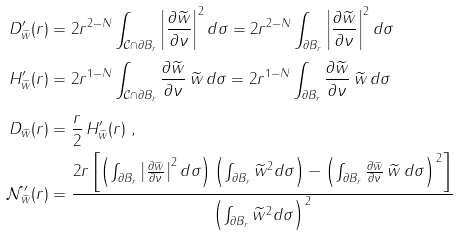<formula> <loc_0><loc_0><loc_500><loc_500>D ^ { \prime } _ { \widetilde { w } } ( r ) & = 2 r ^ { 2 - N } \int _ { \mathcal { C } \cap \partial B _ { r } } \left | \frac { \partial \widetilde { w } } { \partial \nu } \right | ^ { 2 } d \sigma = 2 r ^ { 2 - N } \int _ { \partial B _ { r } } \left | \frac { \partial \widetilde { w } } { \partial \nu } \right | ^ { 2 } d \sigma \\ H ^ { \prime } _ { \widetilde { w } } ( r ) & = 2 r ^ { 1 - N } \int _ { \mathcal { C } \cap \partial B _ { r } } \frac { \partial \widetilde { w } } { \partial \nu } \, \widetilde { w } \, d \sigma = 2 r ^ { 1 - N } \int _ { \partial B _ { r } } \frac { \partial \widetilde { w } } { \partial \nu } \, \widetilde { w } \, d \sigma \\ D _ { \widetilde { w } } ( r ) & = \frac { r } 2 \, H ^ { \prime } _ { \widetilde { w } } ( r ) \ , \\ \mathcal { N } ^ { \prime } _ { \widetilde { w } } ( r ) & = \frac { 2 r \left [ \left ( \int _ { \partial B _ { r } } \left | \frac { \partial \widetilde { w } } { \partial \nu } \right | ^ { 2 } d \sigma \right ) \left ( \int _ { \partial B _ { r } } \widetilde { w } ^ { 2 } d \sigma \right ) - \left ( \int _ { \partial B _ { r } } \frac { \partial \widetilde { w } } { \partial \nu } \, \widetilde { w } \, d \sigma \right ) ^ { \, 2 } \right ] } { \left ( \int _ { \partial B _ { r } } \widetilde { w } ^ { 2 } d \sigma \right ) ^ { \, 2 } }</formula> 